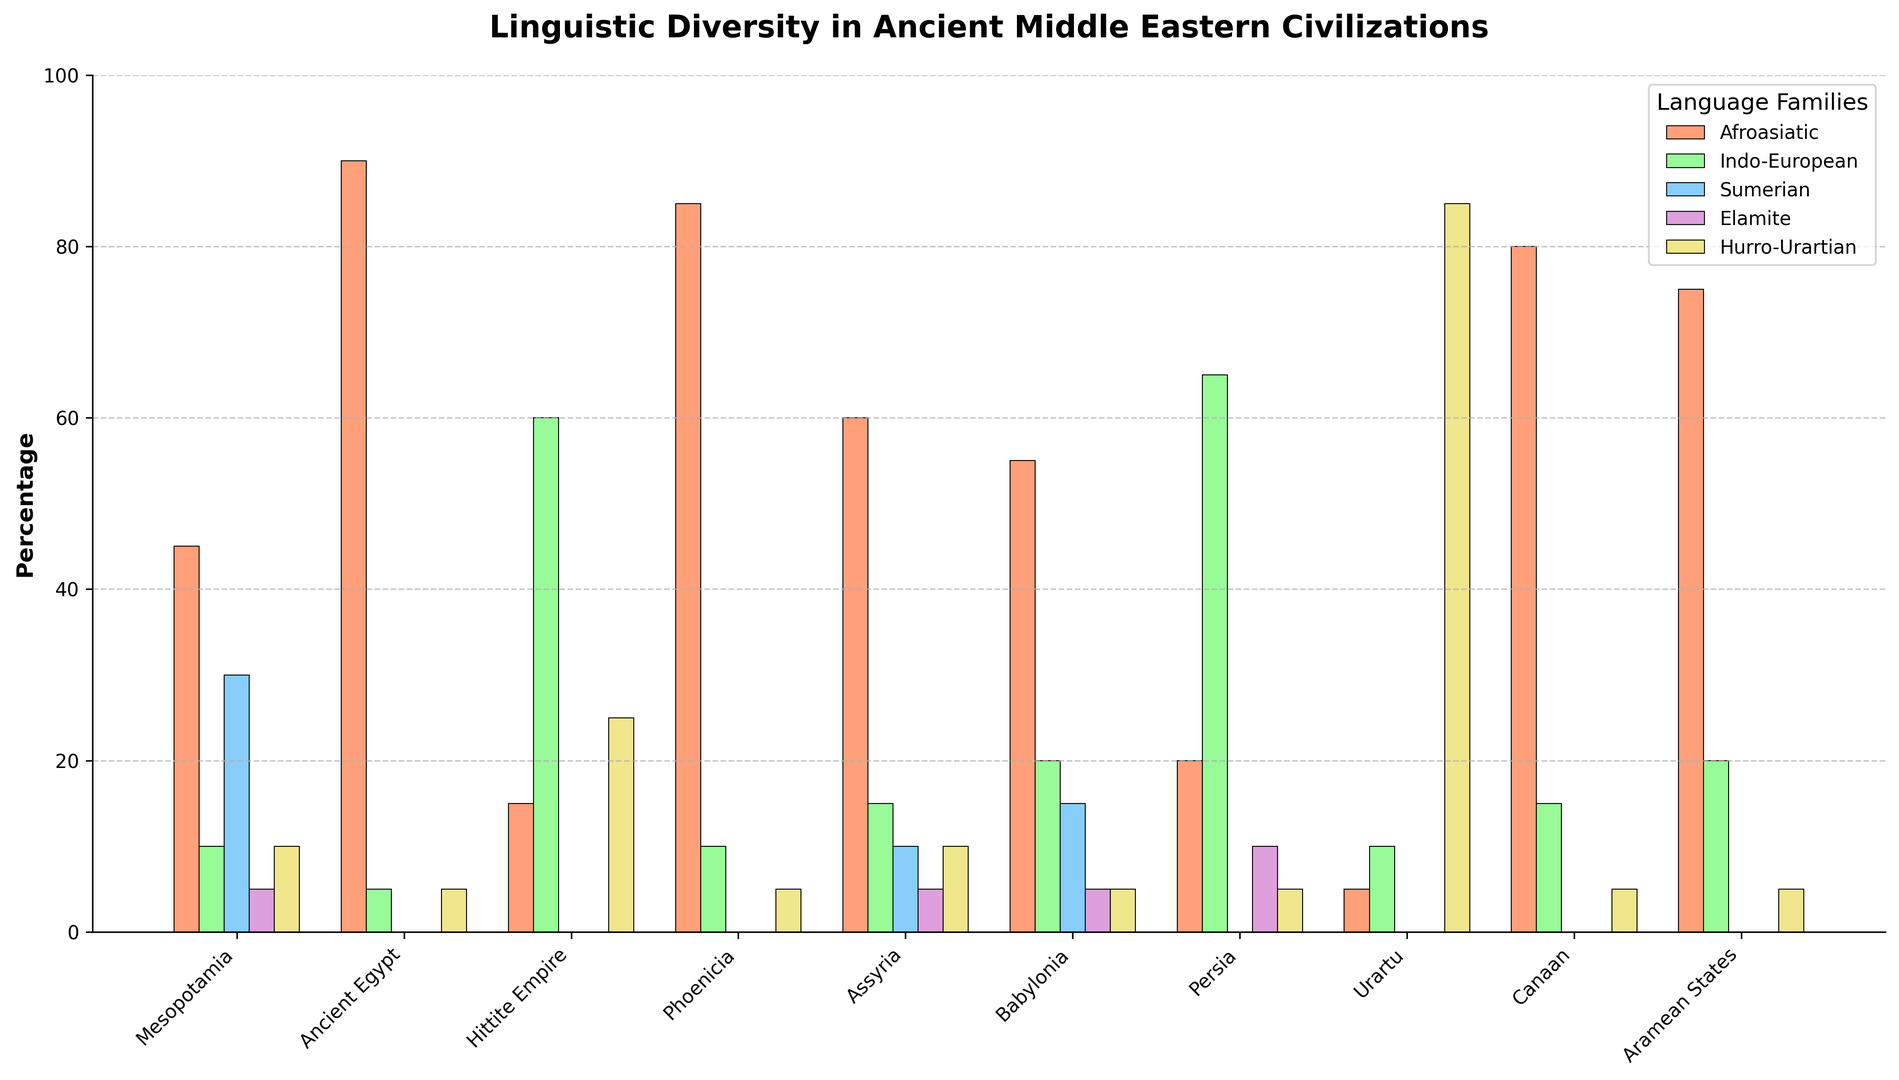How many civilizations have the highest percentage in the Afroasiatic language family? Scan the Afroasiatic bars for each civilization. Mesopotamia (45), Ancient Egypt (90), Hittite Empire (15), Phoenicia (85), Assyria (60), Babylonia (55), Persia (20), Urartu (5), Canaan (80), Aramean States (75). The civilization with the highest percentage is Ancient Egypt with 90.
Answer: 1 Which language family dominates the Hittite Empire? Look at the Hittite Empire's bars and compare the percentages. Afroasiatic (15), Indo-European (60), Sumerian (0), Elamite (0), Hurro-Urartian (25). Indo-European has the highest percentage.
Answer: Indo-European What is the combined percentage of Afroasiatic and Hurro-Urartian languages in Urartu? Identify the percentages for Afroasiatic (5) and Hurro-Urartian (85) in Urartu. Add them together: 5 + 85 = 90.
Answer: 90 Which civilizations have a notable percentage in the Elamite language family? Check each civilization's bar for the Elamite family. Only Mesopotamia (5), Assyria (5), Babylonia (5), and Persia (10) have visible bars.
Answer: Mesopotamia, Assyria, Babylonia, Persia Among the civilizations observed, which one has the least linguistic diversity, considering the variety of language families present? Identify the civilization with the fewest distinct bars with significant heights. Ancient Egypt (two bars of Afroasiatic and Hurro-Urartian), Hittite Empire (Indo-European and Hurro-Urartian). Ancient Egypt has the least diversity.
Answer: Ancient Egypt What percentage of the Indo-European language family is present in Persia compared to the total Indo-European percentage across all civilizations? Sum Indo-European percentages across all civilizations (10+5+60+10+15+20+65+10+15+20=220). Identify Persia's percentage of Indo-European (65). Calculate the percentage: 65/220 × 100 = 29.55%.
Answer: 29.55% Which civilization shows the highest proportional representation of Hurro-Urartian languages? Compare the Hurro-Urartian bars. Urartu has 85%, which is the highest in comparison to all others.
Answer: Urartu How does the percentage of Sumerian in Mesopotamia compare to its percentage in Assyria? Observe the Sumerian bars in Mesopotamia (30) and Assyria (10). The percentage in Mesopotamia (30) is higher than in Assyria (10).
Answer: Mesopotamia > Assyria What is the average percentage of Afroasiatic languages across all civilizations? Sum the Afroasiatic percentages (45+90+15+85+60+55+20+5+80+75) = 530. Divide by the number of civilizations (10). 530 / 10 = 53%.
Answer: 53% Which civilization shows almost an equal representation of Indo-European and Hurro-Urartian language families? Examine the Indo-European and Hurro-Urartian bars for each civilization. The Hittite Empire has 60% Indo-European and 25% Hurro-Urartian.
Answer: Hittite Empire 